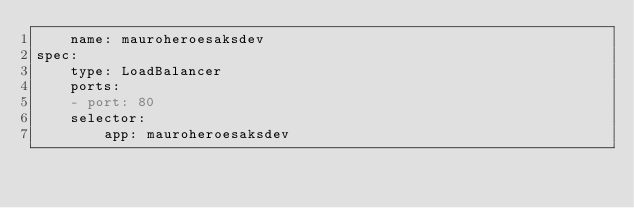Convert code to text. <code><loc_0><loc_0><loc_500><loc_500><_YAML_>    name: mauroheroesaksdev
spec:
    type: LoadBalancer
    ports:
    - port: 80 
    selector:
        app: mauroheroesaksdev</code> 